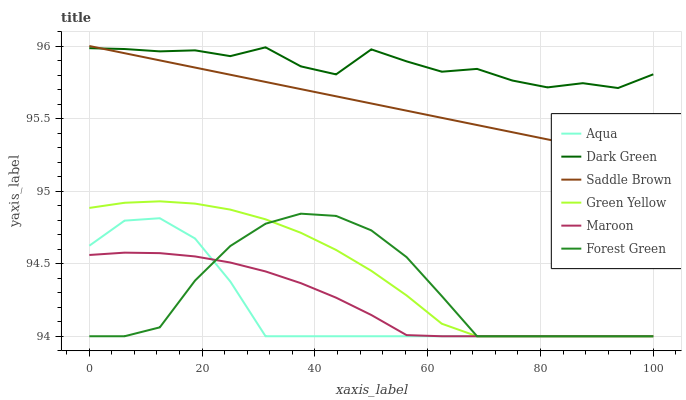Does Aqua have the minimum area under the curve?
Answer yes or no. Yes. Does Dark Green have the maximum area under the curve?
Answer yes or no. Yes. Does Maroon have the minimum area under the curve?
Answer yes or no. No. Does Maroon have the maximum area under the curve?
Answer yes or no. No. Is Saddle Brown the smoothest?
Answer yes or no. Yes. Is Dark Green the roughest?
Answer yes or no. Yes. Is Maroon the smoothest?
Answer yes or no. No. Is Maroon the roughest?
Answer yes or no. No. Does Aqua have the lowest value?
Answer yes or no. Yes. Does Saddle Brown have the lowest value?
Answer yes or no. No. Does Saddle Brown have the highest value?
Answer yes or no. Yes. Does Forest Green have the highest value?
Answer yes or no. No. Is Forest Green less than Saddle Brown?
Answer yes or no. Yes. Is Dark Green greater than Forest Green?
Answer yes or no. Yes. Does Forest Green intersect Maroon?
Answer yes or no. Yes. Is Forest Green less than Maroon?
Answer yes or no. No. Is Forest Green greater than Maroon?
Answer yes or no. No. Does Forest Green intersect Saddle Brown?
Answer yes or no. No. 